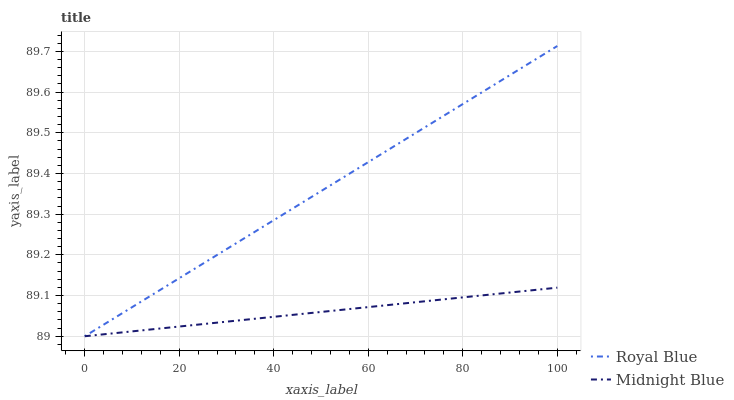Does Midnight Blue have the minimum area under the curve?
Answer yes or no. Yes. Does Royal Blue have the maximum area under the curve?
Answer yes or no. Yes. Does Midnight Blue have the maximum area under the curve?
Answer yes or no. No. Is Midnight Blue the smoothest?
Answer yes or no. Yes. Is Royal Blue the roughest?
Answer yes or no. Yes. Is Midnight Blue the roughest?
Answer yes or no. No. Does Royal Blue have the lowest value?
Answer yes or no. Yes. Does Royal Blue have the highest value?
Answer yes or no. Yes. Does Midnight Blue have the highest value?
Answer yes or no. No. Does Royal Blue intersect Midnight Blue?
Answer yes or no. Yes. Is Royal Blue less than Midnight Blue?
Answer yes or no. No. Is Royal Blue greater than Midnight Blue?
Answer yes or no. No. 